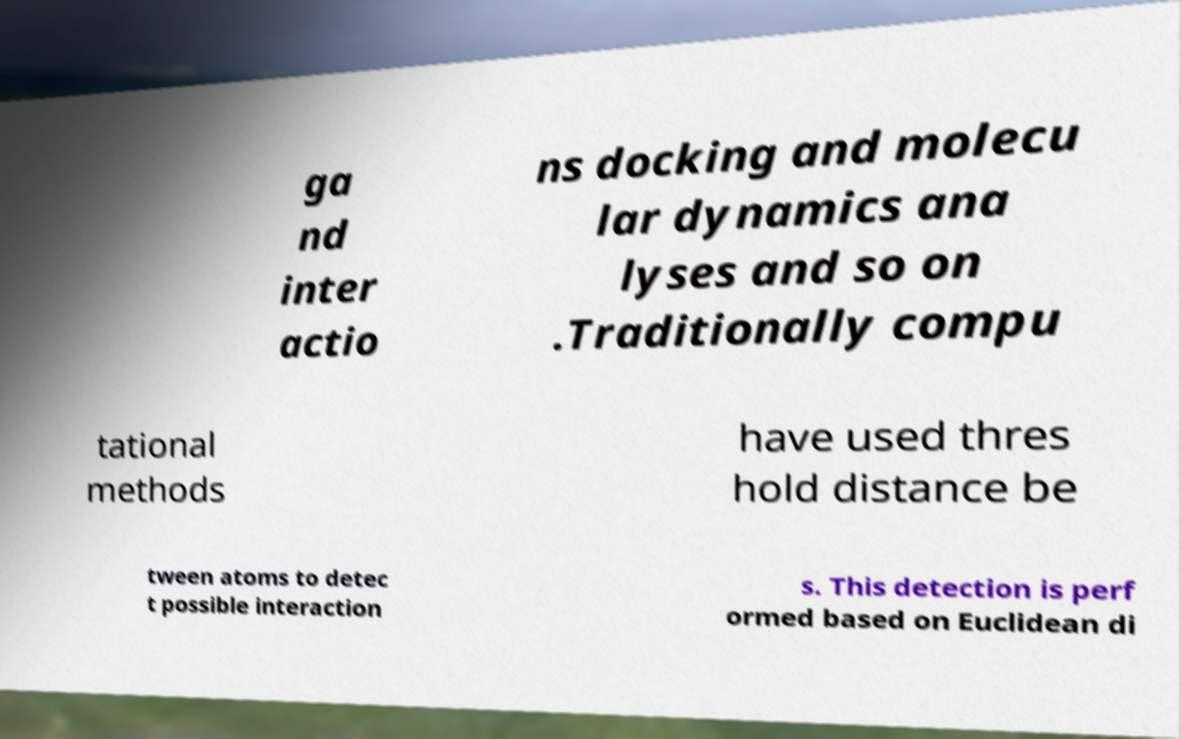There's text embedded in this image that I need extracted. Can you transcribe it verbatim? ga nd inter actio ns docking and molecu lar dynamics ana lyses and so on .Traditionally compu tational methods have used thres hold distance be tween atoms to detec t possible interaction s. This detection is perf ormed based on Euclidean di 